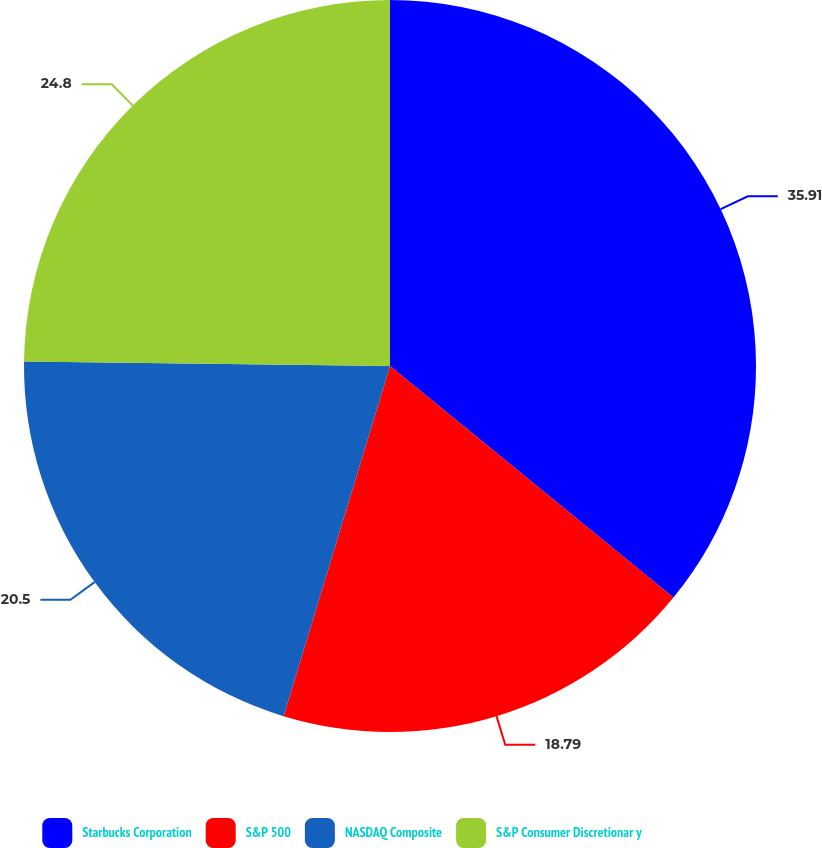Convert chart to OTSL. <chart><loc_0><loc_0><loc_500><loc_500><pie_chart><fcel>Starbucks Corporation<fcel>S&P 500<fcel>NASDAQ Composite<fcel>S&P Consumer Discretionar y<nl><fcel>35.9%<fcel>18.79%<fcel>20.5%<fcel>24.8%<nl></chart> 